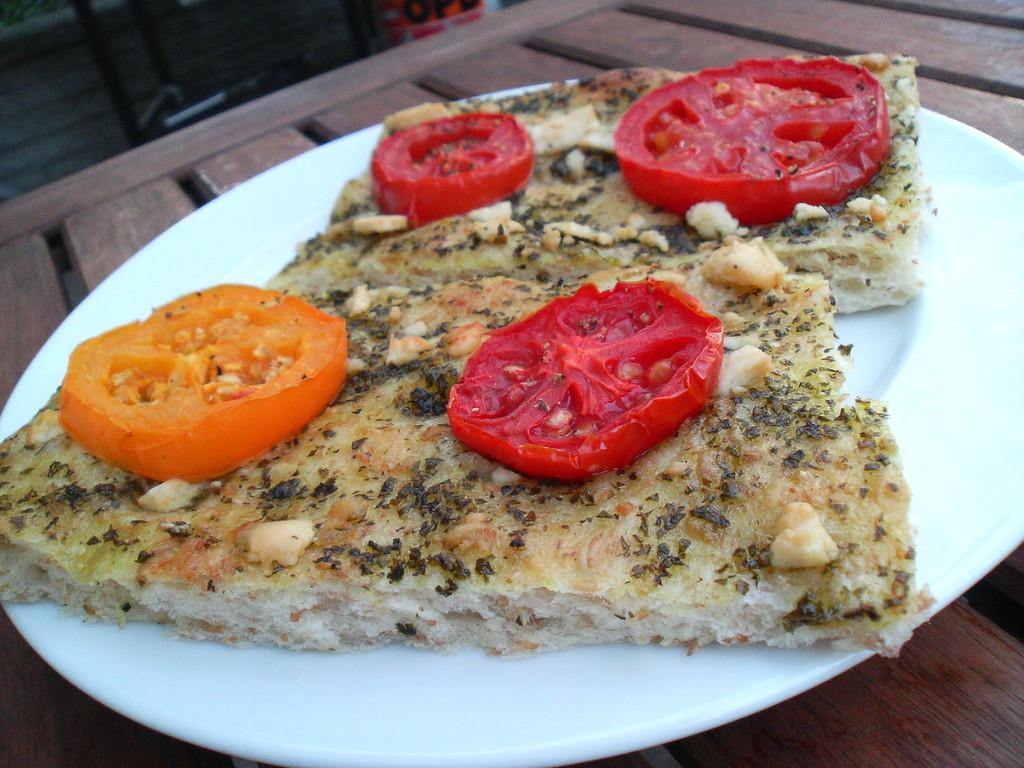Describe this image in one or two sentences. Background portion of the picture is not clear. In this picture on a wooden platform we can see the food, tomato slices placed on a white plate. 